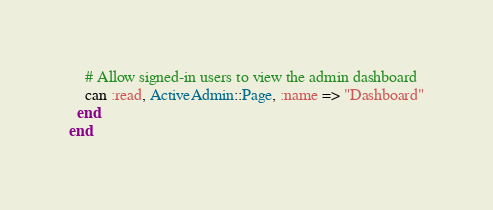Convert code to text. <code><loc_0><loc_0><loc_500><loc_500><_Ruby_>    # Allow signed-in users to view the admin dashboard
    can :read, ActiveAdmin::Page, :name => "Dashboard"
  end
end
</code> 